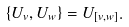<formula> <loc_0><loc_0><loc_500><loc_500>\left \{ U _ { v } , U _ { w } \right \} = U _ { [ v , w ] } .</formula> 